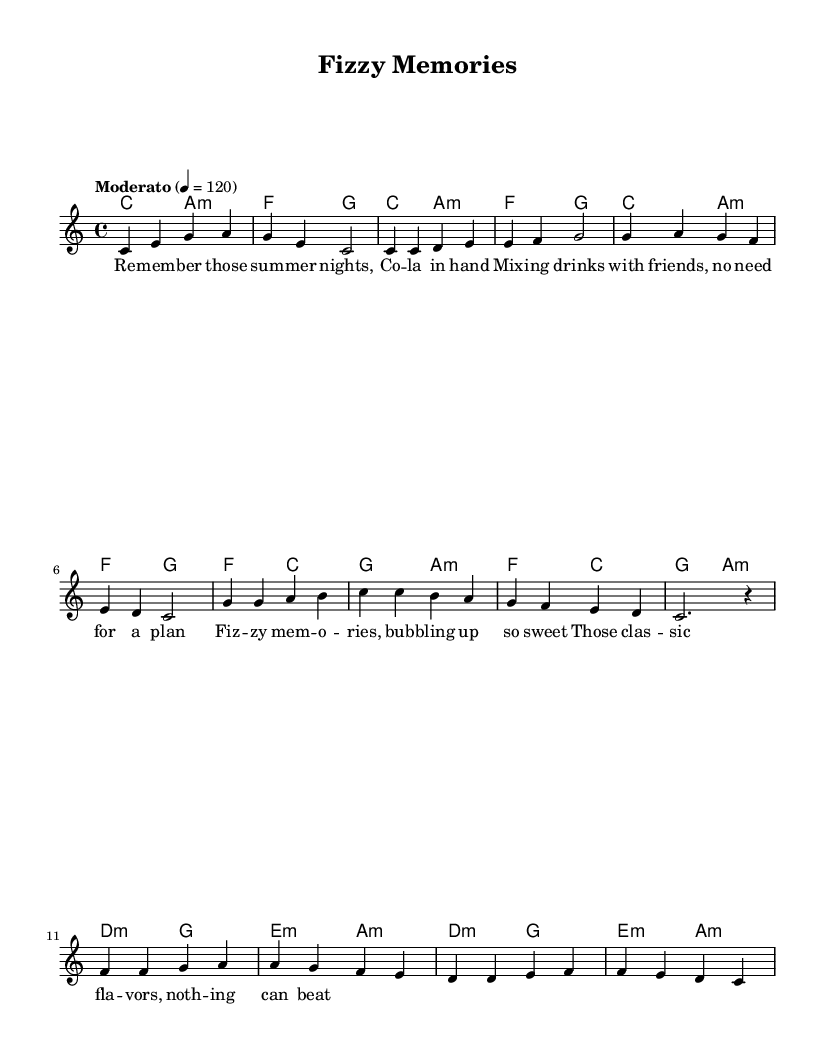What is the key signature of this music? The key signature indicated at the beginning of the sheet music is C major, which has no sharps or flats.
Answer: C major What is the time signature of this music? The time signature shown in the sheet music is 4/4, which means there are four beats in each measure.
Answer: 4/4 What is the tempo marking of this music? The tempo marking at the beginning indicates "Moderato," which generally means a moderate pace, and the metronome marking is 120 beats per minute.
Answer: Moderato, 120 How many measures are in the chorus? The chorus section consists of four measures of music as counted from the musical notation.
Answer: 4 Which chord progresses the bridge? The chords used in the bridge are D minor, G, E minor, and A minor, as explicitly written in the chord changes during this section.
Answer: D minor, G, E minor, A minor What flavor is referenced in the lyrics? The lyrics specifically mention "Cola," which is associated with a classic soft drink, expressing nostalgia for past experiences.
Answer: Cola What is a theme reflected in the lyrics of this song? The lyrics of the song highlight nostalgic sentiments related to summer nights and enjoying fizzy drinks with friends, which captures a sense of reminiscence and joy.
Answer: Nostalgia 